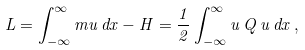Convert formula to latex. <formula><loc_0><loc_0><loc_500><loc_500>L = \int _ { - \infty } ^ { \infty } m u \, d x - H = \frac { 1 } { 2 } \int _ { - \infty } ^ { \infty } u \, Q \, u \, d x \, ,</formula> 